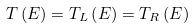<formula> <loc_0><loc_0><loc_500><loc_500>T \left ( E \right ) = T _ { L } \left ( E \right ) = T _ { R } \left ( E \right )</formula> 